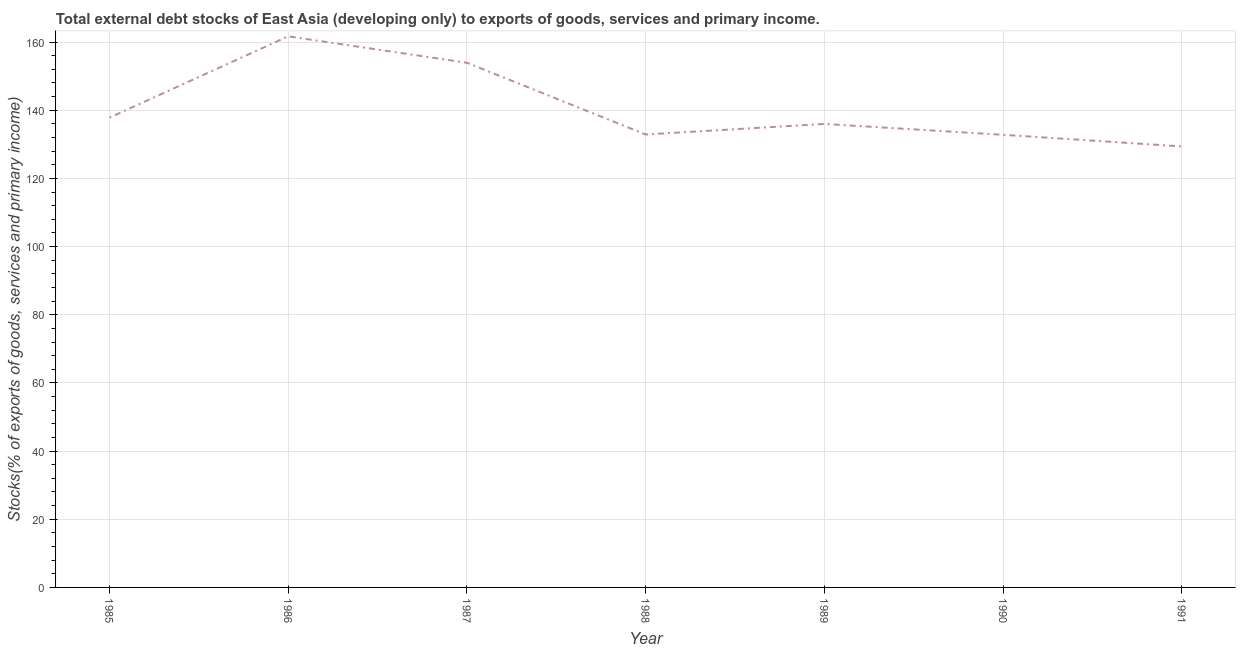What is the external debt stocks in 1989?
Provide a short and direct response. 135.98. Across all years, what is the maximum external debt stocks?
Offer a very short reply. 161.68. Across all years, what is the minimum external debt stocks?
Your answer should be compact. 129.38. What is the sum of the external debt stocks?
Your response must be concise. 984.48. What is the difference between the external debt stocks in 1987 and 1991?
Ensure brevity in your answer.  24.55. What is the average external debt stocks per year?
Ensure brevity in your answer.  140.64. What is the median external debt stocks?
Keep it short and to the point. 135.98. In how many years, is the external debt stocks greater than 112 %?
Give a very brief answer. 7. What is the ratio of the external debt stocks in 1986 to that in 1991?
Make the answer very short. 1.25. What is the difference between the highest and the second highest external debt stocks?
Your answer should be compact. 7.76. Is the sum of the external debt stocks in 1987 and 1991 greater than the maximum external debt stocks across all years?
Provide a succinct answer. Yes. What is the difference between the highest and the lowest external debt stocks?
Your answer should be very brief. 32.3. Does the external debt stocks monotonically increase over the years?
Make the answer very short. No. How many years are there in the graph?
Give a very brief answer. 7. What is the difference between two consecutive major ticks on the Y-axis?
Your response must be concise. 20. What is the title of the graph?
Your answer should be compact. Total external debt stocks of East Asia (developing only) to exports of goods, services and primary income. What is the label or title of the X-axis?
Offer a terse response. Year. What is the label or title of the Y-axis?
Offer a terse response. Stocks(% of exports of goods, services and primary income). What is the Stocks(% of exports of goods, services and primary income) in 1985?
Provide a short and direct response. 137.83. What is the Stocks(% of exports of goods, services and primary income) of 1986?
Provide a short and direct response. 161.68. What is the Stocks(% of exports of goods, services and primary income) in 1987?
Your answer should be compact. 153.93. What is the Stocks(% of exports of goods, services and primary income) in 1988?
Provide a succinct answer. 132.89. What is the Stocks(% of exports of goods, services and primary income) of 1989?
Your answer should be very brief. 135.98. What is the Stocks(% of exports of goods, services and primary income) in 1990?
Provide a succinct answer. 132.79. What is the Stocks(% of exports of goods, services and primary income) in 1991?
Your answer should be very brief. 129.38. What is the difference between the Stocks(% of exports of goods, services and primary income) in 1985 and 1986?
Your answer should be compact. -23.86. What is the difference between the Stocks(% of exports of goods, services and primary income) in 1985 and 1987?
Keep it short and to the point. -16.1. What is the difference between the Stocks(% of exports of goods, services and primary income) in 1985 and 1988?
Make the answer very short. 4.94. What is the difference between the Stocks(% of exports of goods, services and primary income) in 1985 and 1989?
Offer a terse response. 1.84. What is the difference between the Stocks(% of exports of goods, services and primary income) in 1985 and 1990?
Ensure brevity in your answer.  5.03. What is the difference between the Stocks(% of exports of goods, services and primary income) in 1985 and 1991?
Offer a very short reply. 8.45. What is the difference between the Stocks(% of exports of goods, services and primary income) in 1986 and 1987?
Offer a very short reply. 7.76. What is the difference between the Stocks(% of exports of goods, services and primary income) in 1986 and 1988?
Provide a succinct answer. 28.8. What is the difference between the Stocks(% of exports of goods, services and primary income) in 1986 and 1989?
Provide a short and direct response. 25.7. What is the difference between the Stocks(% of exports of goods, services and primary income) in 1986 and 1990?
Your answer should be compact. 28.89. What is the difference between the Stocks(% of exports of goods, services and primary income) in 1986 and 1991?
Provide a succinct answer. 32.3. What is the difference between the Stocks(% of exports of goods, services and primary income) in 1987 and 1988?
Your response must be concise. 21.04. What is the difference between the Stocks(% of exports of goods, services and primary income) in 1987 and 1989?
Make the answer very short. 17.94. What is the difference between the Stocks(% of exports of goods, services and primary income) in 1987 and 1990?
Provide a short and direct response. 21.13. What is the difference between the Stocks(% of exports of goods, services and primary income) in 1987 and 1991?
Your answer should be compact. 24.55. What is the difference between the Stocks(% of exports of goods, services and primary income) in 1988 and 1989?
Your answer should be compact. -3.1. What is the difference between the Stocks(% of exports of goods, services and primary income) in 1988 and 1990?
Provide a short and direct response. 0.09. What is the difference between the Stocks(% of exports of goods, services and primary income) in 1988 and 1991?
Your response must be concise. 3.51. What is the difference between the Stocks(% of exports of goods, services and primary income) in 1989 and 1990?
Your answer should be compact. 3.19. What is the difference between the Stocks(% of exports of goods, services and primary income) in 1989 and 1991?
Give a very brief answer. 6.61. What is the difference between the Stocks(% of exports of goods, services and primary income) in 1990 and 1991?
Make the answer very short. 3.42. What is the ratio of the Stocks(% of exports of goods, services and primary income) in 1985 to that in 1986?
Make the answer very short. 0.85. What is the ratio of the Stocks(% of exports of goods, services and primary income) in 1985 to that in 1987?
Your answer should be very brief. 0.9. What is the ratio of the Stocks(% of exports of goods, services and primary income) in 1985 to that in 1990?
Offer a terse response. 1.04. What is the ratio of the Stocks(% of exports of goods, services and primary income) in 1985 to that in 1991?
Provide a succinct answer. 1.06. What is the ratio of the Stocks(% of exports of goods, services and primary income) in 1986 to that in 1987?
Offer a terse response. 1.05. What is the ratio of the Stocks(% of exports of goods, services and primary income) in 1986 to that in 1988?
Your response must be concise. 1.22. What is the ratio of the Stocks(% of exports of goods, services and primary income) in 1986 to that in 1989?
Ensure brevity in your answer.  1.19. What is the ratio of the Stocks(% of exports of goods, services and primary income) in 1986 to that in 1990?
Your answer should be compact. 1.22. What is the ratio of the Stocks(% of exports of goods, services and primary income) in 1987 to that in 1988?
Provide a short and direct response. 1.16. What is the ratio of the Stocks(% of exports of goods, services and primary income) in 1987 to that in 1989?
Make the answer very short. 1.13. What is the ratio of the Stocks(% of exports of goods, services and primary income) in 1987 to that in 1990?
Provide a short and direct response. 1.16. What is the ratio of the Stocks(% of exports of goods, services and primary income) in 1987 to that in 1991?
Provide a short and direct response. 1.19. What is the ratio of the Stocks(% of exports of goods, services and primary income) in 1988 to that in 1990?
Ensure brevity in your answer.  1. What is the ratio of the Stocks(% of exports of goods, services and primary income) in 1988 to that in 1991?
Offer a terse response. 1.03. What is the ratio of the Stocks(% of exports of goods, services and primary income) in 1989 to that in 1990?
Offer a terse response. 1.02. What is the ratio of the Stocks(% of exports of goods, services and primary income) in 1989 to that in 1991?
Provide a short and direct response. 1.05. 